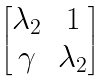Convert formula to latex. <formula><loc_0><loc_0><loc_500><loc_500>\begin{bmatrix} \lambda _ { 2 } & 1 \\ \gamma & \lambda _ { 2 } \end{bmatrix}</formula> 